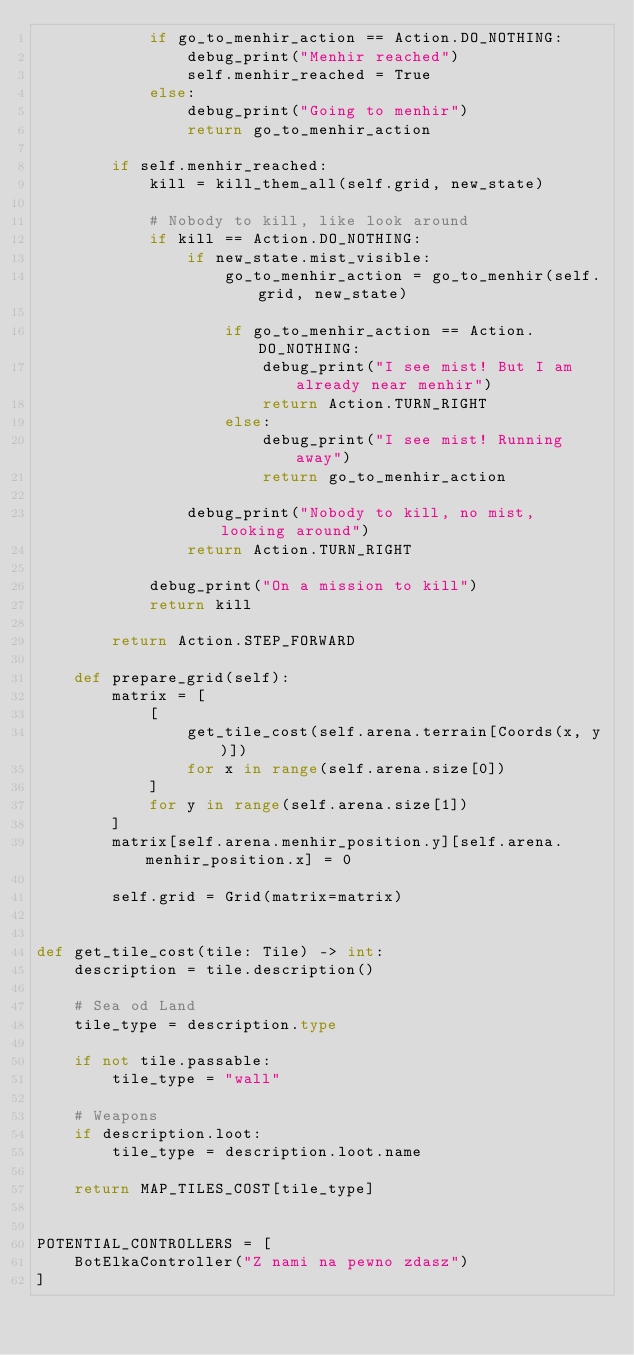Convert code to text. <code><loc_0><loc_0><loc_500><loc_500><_Python_>            if go_to_menhir_action == Action.DO_NOTHING:
                debug_print("Menhir reached")
                self.menhir_reached = True
            else:
                debug_print("Going to menhir")
                return go_to_menhir_action

        if self.menhir_reached:
            kill = kill_them_all(self.grid, new_state)

            # Nobody to kill, like look around
            if kill == Action.DO_NOTHING:
                if new_state.mist_visible:
                    go_to_menhir_action = go_to_menhir(self.grid, new_state)

                    if go_to_menhir_action == Action.DO_NOTHING:
                        debug_print("I see mist! But I am already near menhir")
                        return Action.TURN_RIGHT
                    else:
                        debug_print("I see mist! Running away")
                        return go_to_menhir_action

                debug_print("Nobody to kill, no mist, looking around")
                return Action.TURN_RIGHT

            debug_print("On a mission to kill")
            return kill

        return Action.STEP_FORWARD

    def prepare_grid(self):
        matrix = [
            [
                get_tile_cost(self.arena.terrain[Coords(x, y)])
                for x in range(self.arena.size[0])
            ]
            for y in range(self.arena.size[1])
        ]
        matrix[self.arena.menhir_position.y][self.arena.menhir_position.x] = 0

        self.grid = Grid(matrix=matrix)


def get_tile_cost(tile: Tile) -> int:
    description = tile.description()

    # Sea od Land
    tile_type = description.type

    if not tile.passable:
        tile_type = "wall"

    # Weapons
    if description.loot:
        tile_type = description.loot.name

    return MAP_TILES_COST[tile_type]


POTENTIAL_CONTROLLERS = [
    BotElkaController("Z nami na pewno zdasz")
]
</code> 